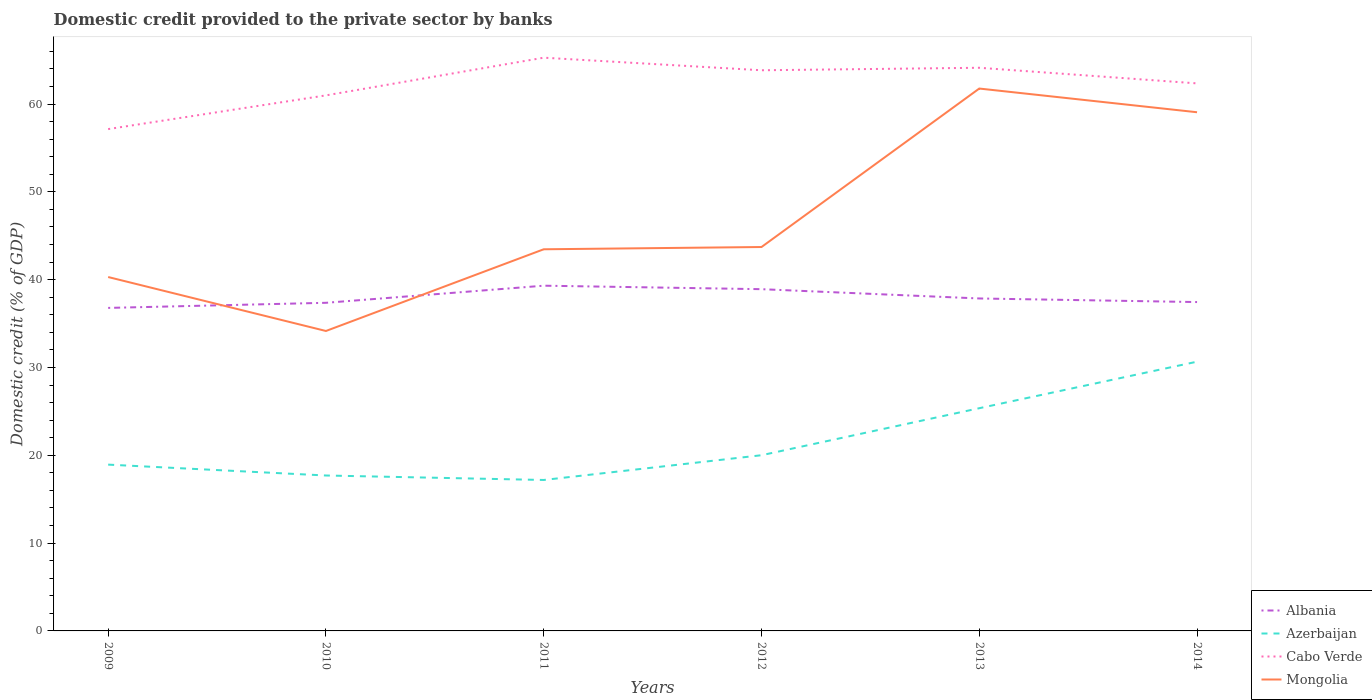Does the line corresponding to Cabo Verde intersect with the line corresponding to Mongolia?
Keep it short and to the point. No. Is the number of lines equal to the number of legend labels?
Make the answer very short. Yes. Across all years, what is the maximum domestic credit provided to the private sector by banks in Albania?
Your response must be concise. 36.78. What is the total domestic credit provided to the private sector by banks in Mongolia in the graph?
Make the answer very short. 2.7. What is the difference between the highest and the second highest domestic credit provided to the private sector by banks in Albania?
Your answer should be very brief. 2.53. What is the difference between the highest and the lowest domestic credit provided to the private sector by banks in Azerbaijan?
Make the answer very short. 2. How many lines are there?
Your response must be concise. 4. What is the difference between two consecutive major ticks on the Y-axis?
Your answer should be very brief. 10. Does the graph contain grids?
Your answer should be very brief. No. What is the title of the graph?
Offer a terse response. Domestic credit provided to the private sector by banks. Does "Kyrgyz Republic" appear as one of the legend labels in the graph?
Provide a short and direct response. No. What is the label or title of the X-axis?
Give a very brief answer. Years. What is the label or title of the Y-axis?
Your answer should be very brief. Domestic credit (% of GDP). What is the Domestic credit (% of GDP) of Albania in 2009?
Make the answer very short. 36.78. What is the Domestic credit (% of GDP) in Azerbaijan in 2009?
Provide a short and direct response. 18.94. What is the Domestic credit (% of GDP) of Cabo Verde in 2009?
Provide a short and direct response. 57.15. What is the Domestic credit (% of GDP) in Mongolia in 2009?
Provide a succinct answer. 40.3. What is the Domestic credit (% of GDP) of Albania in 2010?
Make the answer very short. 37.37. What is the Domestic credit (% of GDP) of Azerbaijan in 2010?
Offer a very short reply. 17.7. What is the Domestic credit (% of GDP) of Cabo Verde in 2010?
Your answer should be compact. 60.99. What is the Domestic credit (% of GDP) in Mongolia in 2010?
Your response must be concise. 34.16. What is the Domestic credit (% of GDP) in Albania in 2011?
Offer a very short reply. 39.31. What is the Domestic credit (% of GDP) in Azerbaijan in 2011?
Your answer should be very brief. 17.19. What is the Domestic credit (% of GDP) of Cabo Verde in 2011?
Keep it short and to the point. 65.28. What is the Domestic credit (% of GDP) of Mongolia in 2011?
Offer a terse response. 43.46. What is the Domestic credit (% of GDP) in Albania in 2012?
Offer a terse response. 38.92. What is the Domestic credit (% of GDP) of Azerbaijan in 2012?
Provide a short and direct response. 20.01. What is the Domestic credit (% of GDP) in Cabo Verde in 2012?
Offer a very short reply. 63.85. What is the Domestic credit (% of GDP) in Mongolia in 2012?
Offer a terse response. 43.72. What is the Domestic credit (% of GDP) of Albania in 2013?
Provide a short and direct response. 37.86. What is the Domestic credit (% of GDP) in Azerbaijan in 2013?
Provide a short and direct response. 25.36. What is the Domestic credit (% of GDP) of Cabo Verde in 2013?
Ensure brevity in your answer.  64.13. What is the Domestic credit (% of GDP) in Mongolia in 2013?
Your answer should be compact. 61.76. What is the Domestic credit (% of GDP) in Albania in 2014?
Keep it short and to the point. 37.45. What is the Domestic credit (% of GDP) of Azerbaijan in 2014?
Make the answer very short. 30.66. What is the Domestic credit (% of GDP) of Cabo Verde in 2014?
Make the answer very short. 62.35. What is the Domestic credit (% of GDP) of Mongolia in 2014?
Offer a terse response. 59.07. Across all years, what is the maximum Domestic credit (% of GDP) in Albania?
Ensure brevity in your answer.  39.31. Across all years, what is the maximum Domestic credit (% of GDP) in Azerbaijan?
Ensure brevity in your answer.  30.66. Across all years, what is the maximum Domestic credit (% of GDP) of Cabo Verde?
Ensure brevity in your answer.  65.28. Across all years, what is the maximum Domestic credit (% of GDP) of Mongolia?
Offer a terse response. 61.76. Across all years, what is the minimum Domestic credit (% of GDP) in Albania?
Provide a succinct answer. 36.78. Across all years, what is the minimum Domestic credit (% of GDP) of Azerbaijan?
Make the answer very short. 17.19. Across all years, what is the minimum Domestic credit (% of GDP) of Cabo Verde?
Make the answer very short. 57.15. Across all years, what is the minimum Domestic credit (% of GDP) in Mongolia?
Offer a terse response. 34.16. What is the total Domestic credit (% of GDP) of Albania in the graph?
Your answer should be very brief. 227.69. What is the total Domestic credit (% of GDP) in Azerbaijan in the graph?
Your answer should be compact. 129.86. What is the total Domestic credit (% of GDP) in Cabo Verde in the graph?
Your answer should be very brief. 373.74. What is the total Domestic credit (% of GDP) in Mongolia in the graph?
Provide a succinct answer. 282.46. What is the difference between the Domestic credit (% of GDP) of Albania in 2009 and that in 2010?
Keep it short and to the point. -0.58. What is the difference between the Domestic credit (% of GDP) in Azerbaijan in 2009 and that in 2010?
Make the answer very short. 1.24. What is the difference between the Domestic credit (% of GDP) in Cabo Verde in 2009 and that in 2010?
Make the answer very short. -3.84. What is the difference between the Domestic credit (% of GDP) in Mongolia in 2009 and that in 2010?
Provide a short and direct response. 6.14. What is the difference between the Domestic credit (% of GDP) in Albania in 2009 and that in 2011?
Give a very brief answer. -2.53. What is the difference between the Domestic credit (% of GDP) in Azerbaijan in 2009 and that in 2011?
Give a very brief answer. 1.75. What is the difference between the Domestic credit (% of GDP) of Cabo Verde in 2009 and that in 2011?
Provide a succinct answer. -8.13. What is the difference between the Domestic credit (% of GDP) of Mongolia in 2009 and that in 2011?
Ensure brevity in your answer.  -3.16. What is the difference between the Domestic credit (% of GDP) of Albania in 2009 and that in 2012?
Offer a terse response. -2.13. What is the difference between the Domestic credit (% of GDP) in Azerbaijan in 2009 and that in 2012?
Give a very brief answer. -1.07. What is the difference between the Domestic credit (% of GDP) in Cabo Verde in 2009 and that in 2012?
Ensure brevity in your answer.  -6.7. What is the difference between the Domestic credit (% of GDP) in Mongolia in 2009 and that in 2012?
Provide a succinct answer. -3.42. What is the difference between the Domestic credit (% of GDP) in Albania in 2009 and that in 2013?
Ensure brevity in your answer.  -1.07. What is the difference between the Domestic credit (% of GDP) in Azerbaijan in 2009 and that in 2013?
Keep it short and to the point. -6.42. What is the difference between the Domestic credit (% of GDP) of Cabo Verde in 2009 and that in 2013?
Provide a succinct answer. -6.98. What is the difference between the Domestic credit (% of GDP) of Mongolia in 2009 and that in 2013?
Your answer should be very brief. -21.46. What is the difference between the Domestic credit (% of GDP) of Albania in 2009 and that in 2014?
Your answer should be compact. -0.66. What is the difference between the Domestic credit (% of GDP) in Azerbaijan in 2009 and that in 2014?
Ensure brevity in your answer.  -11.72. What is the difference between the Domestic credit (% of GDP) in Cabo Verde in 2009 and that in 2014?
Offer a terse response. -5.2. What is the difference between the Domestic credit (% of GDP) of Mongolia in 2009 and that in 2014?
Offer a very short reply. -18.77. What is the difference between the Domestic credit (% of GDP) in Albania in 2010 and that in 2011?
Give a very brief answer. -1.95. What is the difference between the Domestic credit (% of GDP) in Azerbaijan in 2010 and that in 2011?
Keep it short and to the point. 0.51. What is the difference between the Domestic credit (% of GDP) of Cabo Verde in 2010 and that in 2011?
Provide a short and direct response. -4.29. What is the difference between the Domestic credit (% of GDP) in Mongolia in 2010 and that in 2011?
Your answer should be compact. -9.3. What is the difference between the Domestic credit (% of GDP) in Albania in 2010 and that in 2012?
Your response must be concise. -1.55. What is the difference between the Domestic credit (% of GDP) of Azerbaijan in 2010 and that in 2012?
Offer a very short reply. -2.31. What is the difference between the Domestic credit (% of GDP) in Cabo Verde in 2010 and that in 2012?
Ensure brevity in your answer.  -2.86. What is the difference between the Domestic credit (% of GDP) of Mongolia in 2010 and that in 2012?
Ensure brevity in your answer.  -9.56. What is the difference between the Domestic credit (% of GDP) in Albania in 2010 and that in 2013?
Make the answer very short. -0.49. What is the difference between the Domestic credit (% of GDP) in Azerbaijan in 2010 and that in 2013?
Make the answer very short. -7.66. What is the difference between the Domestic credit (% of GDP) in Cabo Verde in 2010 and that in 2013?
Ensure brevity in your answer.  -3.14. What is the difference between the Domestic credit (% of GDP) in Mongolia in 2010 and that in 2013?
Provide a succinct answer. -27.61. What is the difference between the Domestic credit (% of GDP) of Albania in 2010 and that in 2014?
Make the answer very short. -0.08. What is the difference between the Domestic credit (% of GDP) in Azerbaijan in 2010 and that in 2014?
Your answer should be very brief. -12.96. What is the difference between the Domestic credit (% of GDP) of Cabo Verde in 2010 and that in 2014?
Make the answer very short. -1.37. What is the difference between the Domestic credit (% of GDP) in Mongolia in 2010 and that in 2014?
Your answer should be compact. -24.91. What is the difference between the Domestic credit (% of GDP) of Albania in 2011 and that in 2012?
Offer a terse response. 0.4. What is the difference between the Domestic credit (% of GDP) in Azerbaijan in 2011 and that in 2012?
Ensure brevity in your answer.  -2.82. What is the difference between the Domestic credit (% of GDP) of Cabo Verde in 2011 and that in 2012?
Your answer should be very brief. 1.43. What is the difference between the Domestic credit (% of GDP) of Mongolia in 2011 and that in 2012?
Give a very brief answer. -0.26. What is the difference between the Domestic credit (% of GDP) in Albania in 2011 and that in 2013?
Provide a succinct answer. 1.46. What is the difference between the Domestic credit (% of GDP) in Azerbaijan in 2011 and that in 2013?
Provide a short and direct response. -8.17. What is the difference between the Domestic credit (% of GDP) in Cabo Verde in 2011 and that in 2013?
Your answer should be compact. 1.15. What is the difference between the Domestic credit (% of GDP) of Mongolia in 2011 and that in 2013?
Give a very brief answer. -18.3. What is the difference between the Domestic credit (% of GDP) of Albania in 2011 and that in 2014?
Keep it short and to the point. 1.86. What is the difference between the Domestic credit (% of GDP) in Azerbaijan in 2011 and that in 2014?
Your response must be concise. -13.47. What is the difference between the Domestic credit (% of GDP) of Cabo Verde in 2011 and that in 2014?
Your response must be concise. 2.93. What is the difference between the Domestic credit (% of GDP) in Mongolia in 2011 and that in 2014?
Provide a short and direct response. -15.61. What is the difference between the Domestic credit (% of GDP) in Albania in 2012 and that in 2013?
Offer a very short reply. 1.06. What is the difference between the Domestic credit (% of GDP) of Azerbaijan in 2012 and that in 2013?
Ensure brevity in your answer.  -5.35. What is the difference between the Domestic credit (% of GDP) in Cabo Verde in 2012 and that in 2013?
Provide a short and direct response. -0.28. What is the difference between the Domestic credit (% of GDP) in Mongolia in 2012 and that in 2013?
Offer a very short reply. -18.05. What is the difference between the Domestic credit (% of GDP) in Albania in 2012 and that in 2014?
Give a very brief answer. 1.47. What is the difference between the Domestic credit (% of GDP) of Azerbaijan in 2012 and that in 2014?
Ensure brevity in your answer.  -10.65. What is the difference between the Domestic credit (% of GDP) of Cabo Verde in 2012 and that in 2014?
Make the answer very short. 1.49. What is the difference between the Domestic credit (% of GDP) in Mongolia in 2012 and that in 2014?
Make the answer very short. -15.35. What is the difference between the Domestic credit (% of GDP) in Albania in 2013 and that in 2014?
Provide a succinct answer. 0.41. What is the difference between the Domestic credit (% of GDP) of Azerbaijan in 2013 and that in 2014?
Provide a short and direct response. -5.3. What is the difference between the Domestic credit (% of GDP) of Cabo Verde in 2013 and that in 2014?
Your answer should be very brief. 1.78. What is the difference between the Domestic credit (% of GDP) in Mongolia in 2013 and that in 2014?
Make the answer very short. 2.7. What is the difference between the Domestic credit (% of GDP) in Albania in 2009 and the Domestic credit (% of GDP) in Azerbaijan in 2010?
Your response must be concise. 19.09. What is the difference between the Domestic credit (% of GDP) in Albania in 2009 and the Domestic credit (% of GDP) in Cabo Verde in 2010?
Offer a terse response. -24.2. What is the difference between the Domestic credit (% of GDP) in Albania in 2009 and the Domestic credit (% of GDP) in Mongolia in 2010?
Make the answer very short. 2.63. What is the difference between the Domestic credit (% of GDP) of Azerbaijan in 2009 and the Domestic credit (% of GDP) of Cabo Verde in 2010?
Keep it short and to the point. -42.05. What is the difference between the Domestic credit (% of GDP) in Azerbaijan in 2009 and the Domestic credit (% of GDP) in Mongolia in 2010?
Offer a terse response. -15.22. What is the difference between the Domestic credit (% of GDP) in Cabo Verde in 2009 and the Domestic credit (% of GDP) in Mongolia in 2010?
Offer a terse response. 22.99. What is the difference between the Domestic credit (% of GDP) in Albania in 2009 and the Domestic credit (% of GDP) in Azerbaijan in 2011?
Keep it short and to the point. 19.6. What is the difference between the Domestic credit (% of GDP) in Albania in 2009 and the Domestic credit (% of GDP) in Cabo Verde in 2011?
Your response must be concise. -28.49. What is the difference between the Domestic credit (% of GDP) in Albania in 2009 and the Domestic credit (% of GDP) in Mongolia in 2011?
Provide a succinct answer. -6.67. What is the difference between the Domestic credit (% of GDP) in Azerbaijan in 2009 and the Domestic credit (% of GDP) in Cabo Verde in 2011?
Offer a very short reply. -46.34. What is the difference between the Domestic credit (% of GDP) in Azerbaijan in 2009 and the Domestic credit (% of GDP) in Mongolia in 2011?
Provide a succinct answer. -24.52. What is the difference between the Domestic credit (% of GDP) of Cabo Verde in 2009 and the Domestic credit (% of GDP) of Mongolia in 2011?
Give a very brief answer. 13.69. What is the difference between the Domestic credit (% of GDP) in Albania in 2009 and the Domestic credit (% of GDP) in Azerbaijan in 2012?
Ensure brevity in your answer.  16.78. What is the difference between the Domestic credit (% of GDP) of Albania in 2009 and the Domestic credit (% of GDP) of Cabo Verde in 2012?
Provide a succinct answer. -27.06. What is the difference between the Domestic credit (% of GDP) in Albania in 2009 and the Domestic credit (% of GDP) in Mongolia in 2012?
Offer a terse response. -6.93. What is the difference between the Domestic credit (% of GDP) of Azerbaijan in 2009 and the Domestic credit (% of GDP) of Cabo Verde in 2012?
Make the answer very short. -44.91. What is the difference between the Domestic credit (% of GDP) of Azerbaijan in 2009 and the Domestic credit (% of GDP) of Mongolia in 2012?
Keep it short and to the point. -24.78. What is the difference between the Domestic credit (% of GDP) in Cabo Verde in 2009 and the Domestic credit (% of GDP) in Mongolia in 2012?
Provide a short and direct response. 13.43. What is the difference between the Domestic credit (% of GDP) of Albania in 2009 and the Domestic credit (% of GDP) of Azerbaijan in 2013?
Offer a very short reply. 11.42. What is the difference between the Domestic credit (% of GDP) in Albania in 2009 and the Domestic credit (% of GDP) in Cabo Verde in 2013?
Give a very brief answer. -27.34. What is the difference between the Domestic credit (% of GDP) of Albania in 2009 and the Domestic credit (% of GDP) of Mongolia in 2013?
Offer a very short reply. -24.98. What is the difference between the Domestic credit (% of GDP) in Azerbaijan in 2009 and the Domestic credit (% of GDP) in Cabo Verde in 2013?
Give a very brief answer. -45.19. What is the difference between the Domestic credit (% of GDP) in Azerbaijan in 2009 and the Domestic credit (% of GDP) in Mongolia in 2013?
Offer a terse response. -42.83. What is the difference between the Domestic credit (% of GDP) in Cabo Verde in 2009 and the Domestic credit (% of GDP) in Mongolia in 2013?
Make the answer very short. -4.62. What is the difference between the Domestic credit (% of GDP) of Albania in 2009 and the Domestic credit (% of GDP) of Azerbaijan in 2014?
Provide a short and direct response. 6.12. What is the difference between the Domestic credit (% of GDP) of Albania in 2009 and the Domestic credit (% of GDP) of Cabo Verde in 2014?
Offer a very short reply. -25.57. What is the difference between the Domestic credit (% of GDP) in Albania in 2009 and the Domestic credit (% of GDP) in Mongolia in 2014?
Give a very brief answer. -22.28. What is the difference between the Domestic credit (% of GDP) in Azerbaijan in 2009 and the Domestic credit (% of GDP) in Cabo Verde in 2014?
Make the answer very short. -43.41. What is the difference between the Domestic credit (% of GDP) of Azerbaijan in 2009 and the Domestic credit (% of GDP) of Mongolia in 2014?
Your response must be concise. -40.13. What is the difference between the Domestic credit (% of GDP) of Cabo Verde in 2009 and the Domestic credit (% of GDP) of Mongolia in 2014?
Offer a very short reply. -1.92. What is the difference between the Domestic credit (% of GDP) in Albania in 2010 and the Domestic credit (% of GDP) in Azerbaijan in 2011?
Offer a terse response. 20.18. What is the difference between the Domestic credit (% of GDP) in Albania in 2010 and the Domestic credit (% of GDP) in Cabo Verde in 2011?
Your answer should be compact. -27.91. What is the difference between the Domestic credit (% of GDP) of Albania in 2010 and the Domestic credit (% of GDP) of Mongolia in 2011?
Your answer should be very brief. -6.09. What is the difference between the Domestic credit (% of GDP) of Azerbaijan in 2010 and the Domestic credit (% of GDP) of Cabo Verde in 2011?
Offer a very short reply. -47.58. What is the difference between the Domestic credit (% of GDP) of Azerbaijan in 2010 and the Domestic credit (% of GDP) of Mongolia in 2011?
Your response must be concise. -25.76. What is the difference between the Domestic credit (% of GDP) in Cabo Verde in 2010 and the Domestic credit (% of GDP) in Mongolia in 2011?
Keep it short and to the point. 17.53. What is the difference between the Domestic credit (% of GDP) of Albania in 2010 and the Domestic credit (% of GDP) of Azerbaijan in 2012?
Your response must be concise. 17.36. What is the difference between the Domestic credit (% of GDP) of Albania in 2010 and the Domestic credit (% of GDP) of Cabo Verde in 2012?
Make the answer very short. -26.48. What is the difference between the Domestic credit (% of GDP) in Albania in 2010 and the Domestic credit (% of GDP) in Mongolia in 2012?
Provide a succinct answer. -6.35. What is the difference between the Domestic credit (% of GDP) in Azerbaijan in 2010 and the Domestic credit (% of GDP) in Cabo Verde in 2012?
Offer a very short reply. -46.15. What is the difference between the Domestic credit (% of GDP) in Azerbaijan in 2010 and the Domestic credit (% of GDP) in Mongolia in 2012?
Your response must be concise. -26.02. What is the difference between the Domestic credit (% of GDP) in Cabo Verde in 2010 and the Domestic credit (% of GDP) in Mongolia in 2012?
Provide a succinct answer. 17.27. What is the difference between the Domestic credit (% of GDP) in Albania in 2010 and the Domestic credit (% of GDP) in Azerbaijan in 2013?
Keep it short and to the point. 12. What is the difference between the Domestic credit (% of GDP) of Albania in 2010 and the Domestic credit (% of GDP) of Cabo Verde in 2013?
Provide a short and direct response. -26.76. What is the difference between the Domestic credit (% of GDP) in Albania in 2010 and the Domestic credit (% of GDP) in Mongolia in 2013?
Offer a terse response. -24.4. What is the difference between the Domestic credit (% of GDP) in Azerbaijan in 2010 and the Domestic credit (% of GDP) in Cabo Verde in 2013?
Your response must be concise. -46.43. What is the difference between the Domestic credit (% of GDP) in Azerbaijan in 2010 and the Domestic credit (% of GDP) in Mongolia in 2013?
Ensure brevity in your answer.  -44.07. What is the difference between the Domestic credit (% of GDP) of Cabo Verde in 2010 and the Domestic credit (% of GDP) of Mongolia in 2013?
Offer a terse response. -0.78. What is the difference between the Domestic credit (% of GDP) in Albania in 2010 and the Domestic credit (% of GDP) in Azerbaijan in 2014?
Your answer should be very brief. 6.7. What is the difference between the Domestic credit (% of GDP) in Albania in 2010 and the Domestic credit (% of GDP) in Cabo Verde in 2014?
Offer a very short reply. -24.99. What is the difference between the Domestic credit (% of GDP) of Albania in 2010 and the Domestic credit (% of GDP) of Mongolia in 2014?
Your answer should be compact. -21.7. What is the difference between the Domestic credit (% of GDP) in Azerbaijan in 2010 and the Domestic credit (% of GDP) in Cabo Verde in 2014?
Keep it short and to the point. -44.65. What is the difference between the Domestic credit (% of GDP) in Azerbaijan in 2010 and the Domestic credit (% of GDP) in Mongolia in 2014?
Your answer should be very brief. -41.37. What is the difference between the Domestic credit (% of GDP) of Cabo Verde in 2010 and the Domestic credit (% of GDP) of Mongolia in 2014?
Ensure brevity in your answer.  1.92. What is the difference between the Domestic credit (% of GDP) in Albania in 2011 and the Domestic credit (% of GDP) in Azerbaijan in 2012?
Give a very brief answer. 19.31. What is the difference between the Domestic credit (% of GDP) of Albania in 2011 and the Domestic credit (% of GDP) of Cabo Verde in 2012?
Offer a terse response. -24.53. What is the difference between the Domestic credit (% of GDP) in Albania in 2011 and the Domestic credit (% of GDP) in Mongolia in 2012?
Provide a short and direct response. -4.4. What is the difference between the Domestic credit (% of GDP) of Azerbaijan in 2011 and the Domestic credit (% of GDP) of Cabo Verde in 2012?
Offer a terse response. -46.66. What is the difference between the Domestic credit (% of GDP) in Azerbaijan in 2011 and the Domestic credit (% of GDP) in Mongolia in 2012?
Ensure brevity in your answer.  -26.53. What is the difference between the Domestic credit (% of GDP) in Cabo Verde in 2011 and the Domestic credit (% of GDP) in Mongolia in 2012?
Your answer should be compact. 21.56. What is the difference between the Domestic credit (% of GDP) of Albania in 2011 and the Domestic credit (% of GDP) of Azerbaijan in 2013?
Ensure brevity in your answer.  13.95. What is the difference between the Domestic credit (% of GDP) in Albania in 2011 and the Domestic credit (% of GDP) in Cabo Verde in 2013?
Your response must be concise. -24.82. What is the difference between the Domestic credit (% of GDP) of Albania in 2011 and the Domestic credit (% of GDP) of Mongolia in 2013?
Your answer should be very brief. -22.45. What is the difference between the Domestic credit (% of GDP) in Azerbaijan in 2011 and the Domestic credit (% of GDP) in Cabo Verde in 2013?
Your answer should be compact. -46.94. What is the difference between the Domestic credit (% of GDP) in Azerbaijan in 2011 and the Domestic credit (% of GDP) in Mongolia in 2013?
Your response must be concise. -44.57. What is the difference between the Domestic credit (% of GDP) in Cabo Verde in 2011 and the Domestic credit (% of GDP) in Mongolia in 2013?
Make the answer very short. 3.51. What is the difference between the Domestic credit (% of GDP) in Albania in 2011 and the Domestic credit (% of GDP) in Azerbaijan in 2014?
Keep it short and to the point. 8.65. What is the difference between the Domestic credit (% of GDP) in Albania in 2011 and the Domestic credit (% of GDP) in Cabo Verde in 2014?
Make the answer very short. -23.04. What is the difference between the Domestic credit (% of GDP) of Albania in 2011 and the Domestic credit (% of GDP) of Mongolia in 2014?
Give a very brief answer. -19.75. What is the difference between the Domestic credit (% of GDP) in Azerbaijan in 2011 and the Domestic credit (% of GDP) in Cabo Verde in 2014?
Make the answer very short. -45.16. What is the difference between the Domestic credit (% of GDP) in Azerbaijan in 2011 and the Domestic credit (% of GDP) in Mongolia in 2014?
Your answer should be compact. -41.88. What is the difference between the Domestic credit (% of GDP) of Cabo Verde in 2011 and the Domestic credit (% of GDP) of Mongolia in 2014?
Give a very brief answer. 6.21. What is the difference between the Domestic credit (% of GDP) of Albania in 2012 and the Domestic credit (% of GDP) of Azerbaijan in 2013?
Your answer should be very brief. 13.55. What is the difference between the Domestic credit (% of GDP) in Albania in 2012 and the Domestic credit (% of GDP) in Cabo Verde in 2013?
Your answer should be very brief. -25.21. What is the difference between the Domestic credit (% of GDP) of Albania in 2012 and the Domestic credit (% of GDP) of Mongolia in 2013?
Ensure brevity in your answer.  -22.85. What is the difference between the Domestic credit (% of GDP) in Azerbaijan in 2012 and the Domestic credit (% of GDP) in Cabo Verde in 2013?
Provide a succinct answer. -44.12. What is the difference between the Domestic credit (% of GDP) of Azerbaijan in 2012 and the Domestic credit (% of GDP) of Mongolia in 2013?
Ensure brevity in your answer.  -41.76. What is the difference between the Domestic credit (% of GDP) of Cabo Verde in 2012 and the Domestic credit (% of GDP) of Mongolia in 2013?
Keep it short and to the point. 2.08. What is the difference between the Domestic credit (% of GDP) in Albania in 2012 and the Domestic credit (% of GDP) in Azerbaijan in 2014?
Your response must be concise. 8.26. What is the difference between the Domestic credit (% of GDP) in Albania in 2012 and the Domestic credit (% of GDP) in Cabo Verde in 2014?
Offer a terse response. -23.43. What is the difference between the Domestic credit (% of GDP) of Albania in 2012 and the Domestic credit (% of GDP) of Mongolia in 2014?
Provide a short and direct response. -20.15. What is the difference between the Domestic credit (% of GDP) in Azerbaijan in 2012 and the Domestic credit (% of GDP) in Cabo Verde in 2014?
Give a very brief answer. -42.34. What is the difference between the Domestic credit (% of GDP) of Azerbaijan in 2012 and the Domestic credit (% of GDP) of Mongolia in 2014?
Offer a terse response. -39.06. What is the difference between the Domestic credit (% of GDP) of Cabo Verde in 2012 and the Domestic credit (% of GDP) of Mongolia in 2014?
Your answer should be very brief. 4.78. What is the difference between the Domestic credit (% of GDP) of Albania in 2013 and the Domestic credit (% of GDP) of Azerbaijan in 2014?
Your answer should be very brief. 7.2. What is the difference between the Domestic credit (% of GDP) of Albania in 2013 and the Domestic credit (% of GDP) of Cabo Verde in 2014?
Provide a short and direct response. -24.49. What is the difference between the Domestic credit (% of GDP) of Albania in 2013 and the Domestic credit (% of GDP) of Mongolia in 2014?
Keep it short and to the point. -21.21. What is the difference between the Domestic credit (% of GDP) of Azerbaijan in 2013 and the Domestic credit (% of GDP) of Cabo Verde in 2014?
Make the answer very short. -36.99. What is the difference between the Domestic credit (% of GDP) in Azerbaijan in 2013 and the Domestic credit (% of GDP) in Mongolia in 2014?
Provide a succinct answer. -33.7. What is the difference between the Domestic credit (% of GDP) in Cabo Verde in 2013 and the Domestic credit (% of GDP) in Mongolia in 2014?
Provide a succinct answer. 5.06. What is the average Domestic credit (% of GDP) in Albania per year?
Offer a very short reply. 37.95. What is the average Domestic credit (% of GDP) of Azerbaijan per year?
Provide a succinct answer. 21.64. What is the average Domestic credit (% of GDP) of Cabo Verde per year?
Offer a very short reply. 62.29. What is the average Domestic credit (% of GDP) of Mongolia per year?
Make the answer very short. 47.08. In the year 2009, what is the difference between the Domestic credit (% of GDP) in Albania and Domestic credit (% of GDP) in Azerbaijan?
Make the answer very short. 17.85. In the year 2009, what is the difference between the Domestic credit (% of GDP) in Albania and Domestic credit (% of GDP) in Cabo Verde?
Provide a succinct answer. -20.36. In the year 2009, what is the difference between the Domestic credit (% of GDP) in Albania and Domestic credit (% of GDP) in Mongolia?
Your response must be concise. -3.51. In the year 2009, what is the difference between the Domestic credit (% of GDP) of Azerbaijan and Domestic credit (% of GDP) of Cabo Verde?
Your answer should be compact. -38.21. In the year 2009, what is the difference between the Domestic credit (% of GDP) in Azerbaijan and Domestic credit (% of GDP) in Mongolia?
Your response must be concise. -21.36. In the year 2009, what is the difference between the Domestic credit (% of GDP) of Cabo Verde and Domestic credit (% of GDP) of Mongolia?
Make the answer very short. 16.85. In the year 2010, what is the difference between the Domestic credit (% of GDP) of Albania and Domestic credit (% of GDP) of Azerbaijan?
Provide a succinct answer. 19.67. In the year 2010, what is the difference between the Domestic credit (% of GDP) of Albania and Domestic credit (% of GDP) of Cabo Verde?
Provide a short and direct response. -23.62. In the year 2010, what is the difference between the Domestic credit (% of GDP) in Albania and Domestic credit (% of GDP) in Mongolia?
Provide a succinct answer. 3.21. In the year 2010, what is the difference between the Domestic credit (% of GDP) in Azerbaijan and Domestic credit (% of GDP) in Cabo Verde?
Your response must be concise. -43.29. In the year 2010, what is the difference between the Domestic credit (% of GDP) of Azerbaijan and Domestic credit (% of GDP) of Mongolia?
Make the answer very short. -16.46. In the year 2010, what is the difference between the Domestic credit (% of GDP) in Cabo Verde and Domestic credit (% of GDP) in Mongolia?
Offer a terse response. 26.83. In the year 2011, what is the difference between the Domestic credit (% of GDP) of Albania and Domestic credit (% of GDP) of Azerbaijan?
Your answer should be compact. 22.12. In the year 2011, what is the difference between the Domestic credit (% of GDP) of Albania and Domestic credit (% of GDP) of Cabo Verde?
Offer a very short reply. -25.96. In the year 2011, what is the difference between the Domestic credit (% of GDP) of Albania and Domestic credit (% of GDP) of Mongolia?
Offer a very short reply. -4.15. In the year 2011, what is the difference between the Domestic credit (% of GDP) of Azerbaijan and Domestic credit (% of GDP) of Cabo Verde?
Make the answer very short. -48.09. In the year 2011, what is the difference between the Domestic credit (% of GDP) of Azerbaijan and Domestic credit (% of GDP) of Mongolia?
Your answer should be very brief. -26.27. In the year 2011, what is the difference between the Domestic credit (% of GDP) of Cabo Verde and Domestic credit (% of GDP) of Mongolia?
Your response must be concise. 21.82. In the year 2012, what is the difference between the Domestic credit (% of GDP) in Albania and Domestic credit (% of GDP) in Azerbaijan?
Keep it short and to the point. 18.91. In the year 2012, what is the difference between the Domestic credit (% of GDP) of Albania and Domestic credit (% of GDP) of Cabo Verde?
Provide a succinct answer. -24.93. In the year 2012, what is the difference between the Domestic credit (% of GDP) of Albania and Domestic credit (% of GDP) of Mongolia?
Ensure brevity in your answer.  -4.8. In the year 2012, what is the difference between the Domestic credit (% of GDP) of Azerbaijan and Domestic credit (% of GDP) of Cabo Verde?
Provide a short and direct response. -43.84. In the year 2012, what is the difference between the Domestic credit (% of GDP) in Azerbaijan and Domestic credit (% of GDP) in Mongolia?
Make the answer very short. -23.71. In the year 2012, what is the difference between the Domestic credit (% of GDP) of Cabo Verde and Domestic credit (% of GDP) of Mongolia?
Provide a succinct answer. 20.13. In the year 2013, what is the difference between the Domestic credit (% of GDP) of Albania and Domestic credit (% of GDP) of Azerbaijan?
Make the answer very short. 12.5. In the year 2013, what is the difference between the Domestic credit (% of GDP) of Albania and Domestic credit (% of GDP) of Cabo Verde?
Keep it short and to the point. -26.27. In the year 2013, what is the difference between the Domestic credit (% of GDP) in Albania and Domestic credit (% of GDP) in Mongolia?
Ensure brevity in your answer.  -23.91. In the year 2013, what is the difference between the Domestic credit (% of GDP) of Azerbaijan and Domestic credit (% of GDP) of Cabo Verde?
Your response must be concise. -38.77. In the year 2013, what is the difference between the Domestic credit (% of GDP) of Azerbaijan and Domestic credit (% of GDP) of Mongolia?
Your answer should be very brief. -36.4. In the year 2013, what is the difference between the Domestic credit (% of GDP) in Cabo Verde and Domestic credit (% of GDP) in Mongolia?
Your answer should be compact. 2.37. In the year 2014, what is the difference between the Domestic credit (% of GDP) of Albania and Domestic credit (% of GDP) of Azerbaijan?
Keep it short and to the point. 6.79. In the year 2014, what is the difference between the Domestic credit (% of GDP) in Albania and Domestic credit (% of GDP) in Cabo Verde?
Make the answer very short. -24.9. In the year 2014, what is the difference between the Domestic credit (% of GDP) of Albania and Domestic credit (% of GDP) of Mongolia?
Your answer should be very brief. -21.62. In the year 2014, what is the difference between the Domestic credit (% of GDP) of Azerbaijan and Domestic credit (% of GDP) of Cabo Verde?
Offer a terse response. -31.69. In the year 2014, what is the difference between the Domestic credit (% of GDP) of Azerbaijan and Domestic credit (% of GDP) of Mongolia?
Your response must be concise. -28.4. In the year 2014, what is the difference between the Domestic credit (% of GDP) in Cabo Verde and Domestic credit (% of GDP) in Mongolia?
Give a very brief answer. 3.29. What is the ratio of the Domestic credit (% of GDP) of Albania in 2009 to that in 2010?
Provide a short and direct response. 0.98. What is the ratio of the Domestic credit (% of GDP) of Azerbaijan in 2009 to that in 2010?
Your answer should be very brief. 1.07. What is the ratio of the Domestic credit (% of GDP) in Cabo Verde in 2009 to that in 2010?
Your response must be concise. 0.94. What is the ratio of the Domestic credit (% of GDP) of Mongolia in 2009 to that in 2010?
Your answer should be very brief. 1.18. What is the ratio of the Domestic credit (% of GDP) in Albania in 2009 to that in 2011?
Offer a very short reply. 0.94. What is the ratio of the Domestic credit (% of GDP) of Azerbaijan in 2009 to that in 2011?
Ensure brevity in your answer.  1.1. What is the ratio of the Domestic credit (% of GDP) in Cabo Verde in 2009 to that in 2011?
Give a very brief answer. 0.88. What is the ratio of the Domestic credit (% of GDP) of Mongolia in 2009 to that in 2011?
Offer a very short reply. 0.93. What is the ratio of the Domestic credit (% of GDP) in Albania in 2009 to that in 2012?
Offer a terse response. 0.95. What is the ratio of the Domestic credit (% of GDP) in Azerbaijan in 2009 to that in 2012?
Your response must be concise. 0.95. What is the ratio of the Domestic credit (% of GDP) of Cabo Verde in 2009 to that in 2012?
Provide a succinct answer. 0.9. What is the ratio of the Domestic credit (% of GDP) of Mongolia in 2009 to that in 2012?
Your answer should be very brief. 0.92. What is the ratio of the Domestic credit (% of GDP) in Albania in 2009 to that in 2013?
Provide a short and direct response. 0.97. What is the ratio of the Domestic credit (% of GDP) of Azerbaijan in 2009 to that in 2013?
Keep it short and to the point. 0.75. What is the ratio of the Domestic credit (% of GDP) of Cabo Verde in 2009 to that in 2013?
Provide a short and direct response. 0.89. What is the ratio of the Domestic credit (% of GDP) of Mongolia in 2009 to that in 2013?
Your answer should be compact. 0.65. What is the ratio of the Domestic credit (% of GDP) in Albania in 2009 to that in 2014?
Ensure brevity in your answer.  0.98. What is the ratio of the Domestic credit (% of GDP) in Azerbaijan in 2009 to that in 2014?
Your answer should be compact. 0.62. What is the ratio of the Domestic credit (% of GDP) of Cabo Verde in 2009 to that in 2014?
Your answer should be very brief. 0.92. What is the ratio of the Domestic credit (% of GDP) of Mongolia in 2009 to that in 2014?
Offer a very short reply. 0.68. What is the ratio of the Domestic credit (% of GDP) of Albania in 2010 to that in 2011?
Ensure brevity in your answer.  0.95. What is the ratio of the Domestic credit (% of GDP) in Azerbaijan in 2010 to that in 2011?
Ensure brevity in your answer.  1.03. What is the ratio of the Domestic credit (% of GDP) of Cabo Verde in 2010 to that in 2011?
Your answer should be very brief. 0.93. What is the ratio of the Domestic credit (% of GDP) of Mongolia in 2010 to that in 2011?
Give a very brief answer. 0.79. What is the ratio of the Domestic credit (% of GDP) in Albania in 2010 to that in 2012?
Your response must be concise. 0.96. What is the ratio of the Domestic credit (% of GDP) in Azerbaijan in 2010 to that in 2012?
Give a very brief answer. 0.88. What is the ratio of the Domestic credit (% of GDP) of Cabo Verde in 2010 to that in 2012?
Offer a terse response. 0.96. What is the ratio of the Domestic credit (% of GDP) in Mongolia in 2010 to that in 2012?
Your answer should be compact. 0.78. What is the ratio of the Domestic credit (% of GDP) of Azerbaijan in 2010 to that in 2013?
Provide a succinct answer. 0.7. What is the ratio of the Domestic credit (% of GDP) in Cabo Verde in 2010 to that in 2013?
Your answer should be very brief. 0.95. What is the ratio of the Domestic credit (% of GDP) of Mongolia in 2010 to that in 2013?
Keep it short and to the point. 0.55. What is the ratio of the Domestic credit (% of GDP) of Albania in 2010 to that in 2014?
Your answer should be compact. 1. What is the ratio of the Domestic credit (% of GDP) of Azerbaijan in 2010 to that in 2014?
Ensure brevity in your answer.  0.58. What is the ratio of the Domestic credit (% of GDP) of Cabo Verde in 2010 to that in 2014?
Provide a short and direct response. 0.98. What is the ratio of the Domestic credit (% of GDP) of Mongolia in 2010 to that in 2014?
Give a very brief answer. 0.58. What is the ratio of the Domestic credit (% of GDP) in Albania in 2011 to that in 2012?
Keep it short and to the point. 1.01. What is the ratio of the Domestic credit (% of GDP) of Azerbaijan in 2011 to that in 2012?
Provide a succinct answer. 0.86. What is the ratio of the Domestic credit (% of GDP) in Cabo Verde in 2011 to that in 2012?
Keep it short and to the point. 1.02. What is the ratio of the Domestic credit (% of GDP) in Mongolia in 2011 to that in 2012?
Offer a very short reply. 0.99. What is the ratio of the Domestic credit (% of GDP) of Albania in 2011 to that in 2013?
Keep it short and to the point. 1.04. What is the ratio of the Domestic credit (% of GDP) of Azerbaijan in 2011 to that in 2013?
Provide a short and direct response. 0.68. What is the ratio of the Domestic credit (% of GDP) of Cabo Verde in 2011 to that in 2013?
Ensure brevity in your answer.  1.02. What is the ratio of the Domestic credit (% of GDP) of Mongolia in 2011 to that in 2013?
Make the answer very short. 0.7. What is the ratio of the Domestic credit (% of GDP) in Albania in 2011 to that in 2014?
Provide a succinct answer. 1.05. What is the ratio of the Domestic credit (% of GDP) in Azerbaijan in 2011 to that in 2014?
Offer a terse response. 0.56. What is the ratio of the Domestic credit (% of GDP) of Cabo Verde in 2011 to that in 2014?
Make the answer very short. 1.05. What is the ratio of the Domestic credit (% of GDP) in Mongolia in 2011 to that in 2014?
Your response must be concise. 0.74. What is the ratio of the Domestic credit (% of GDP) of Albania in 2012 to that in 2013?
Provide a short and direct response. 1.03. What is the ratio of the Domestic credit (% of GDP) in Azerbaijan in 2012 to that in 2013?
Keep it short and to the point. 0.79. What is the ratio of the Domestic credit (% of GDP) of Mongolia in 2012 to that in 2013?
Offer a terse response. 0.71. What is the ratio of the Domestic credit (% of GDP) of Albania in 2012 to that in 2014?
Your answer should be very brief. 1.04. What is the ratio of the Domestic credit (% of GDP) in Azerbaijan in 2012 to that in 2014?
Your answer should be very brief. 0.65. What is the ratio of the Domestic credit (% of GDP) of Cabo Verde in 2012 to that in 2014?
Keep it short and to the point. 1.02. What is the ratio of the Domestic credit (% of GDP) of Mongolia in 2012 to that in 2014?
Provide a short and direct response. 0.74. What is the ratio of the Domestic credit (% of GDP) of Albania in 2013 to that in 2014?
Ensure brevity in your answer.  1.01. What is the ratio of the Domestic credit (% of GDP) of Azerbaijan in 2013 to that in 2014?
Provide a succinct answer. 0.83. What is the ratio of the Domestic credit (% of GDP) in Cabo Verde in 2013 to that in 2014?
Ensure brevity in your answer.  1.03. What is the ratio of the Domestic credit (% of GDP) of Mongolia in 2013 to that in 2014?
Your answer should be compact. 1.05. What is the difference between the highest and the second highest Domestic credit (% of GDP) of Albania?
Your response must be concise. 0.4. What is the difference between the highest and the second highest Domestic credit (% of GDP) of Azerbaijan?
Provide a short and direct response. 5.3. What is the difference between the highest and the second highest Domestic credit (% of GDP) of Cabo Verde?
Provide a succinct answer. 1.15. What is the difference between the highest and the second highest Domestic credit (% of GDP) of Mongolia?
Provide a succinct answer. 2.7. What is the difference between the highest and the lowest Domestic credit (% of GDP) in Albania?
Your answer should be compact. 2.53. What is the difference between the highest and the lowest Domestic credit (% of GDP) of Azerbaijan?
Your answer should be compact. 13.47. What is the difference between the highest and the lowest Domestic credit (% of GDP) in Cabo Verde?
Provide a succinct answer. 8.13. What is the difference between the highest and the lowest Domestic credit (% of GDP) in Mongolia?
Give a very brief answer. 27.61. 